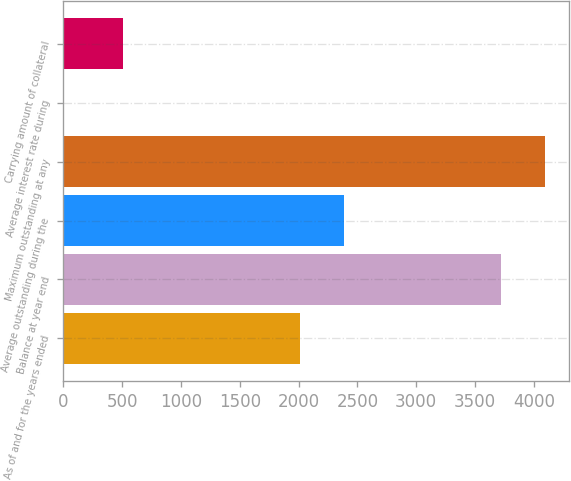Convert chart to OTSL. <chart><loc_0><loc_0><loc_500><loc_500><bar_chart><fcel>As of and for the years ended<fcel>Balance at year end<fcel>Average outstanding during the<fcel>Maximum outstanding at any<fcel>Average interest rate during<fcel>Carrying amount of collateral<nl><fcel>2013<fcel>3719.8<fcel>2384.94<fcel>4091.74<fcel>0.4<fcel>511.2<nl></chart> 